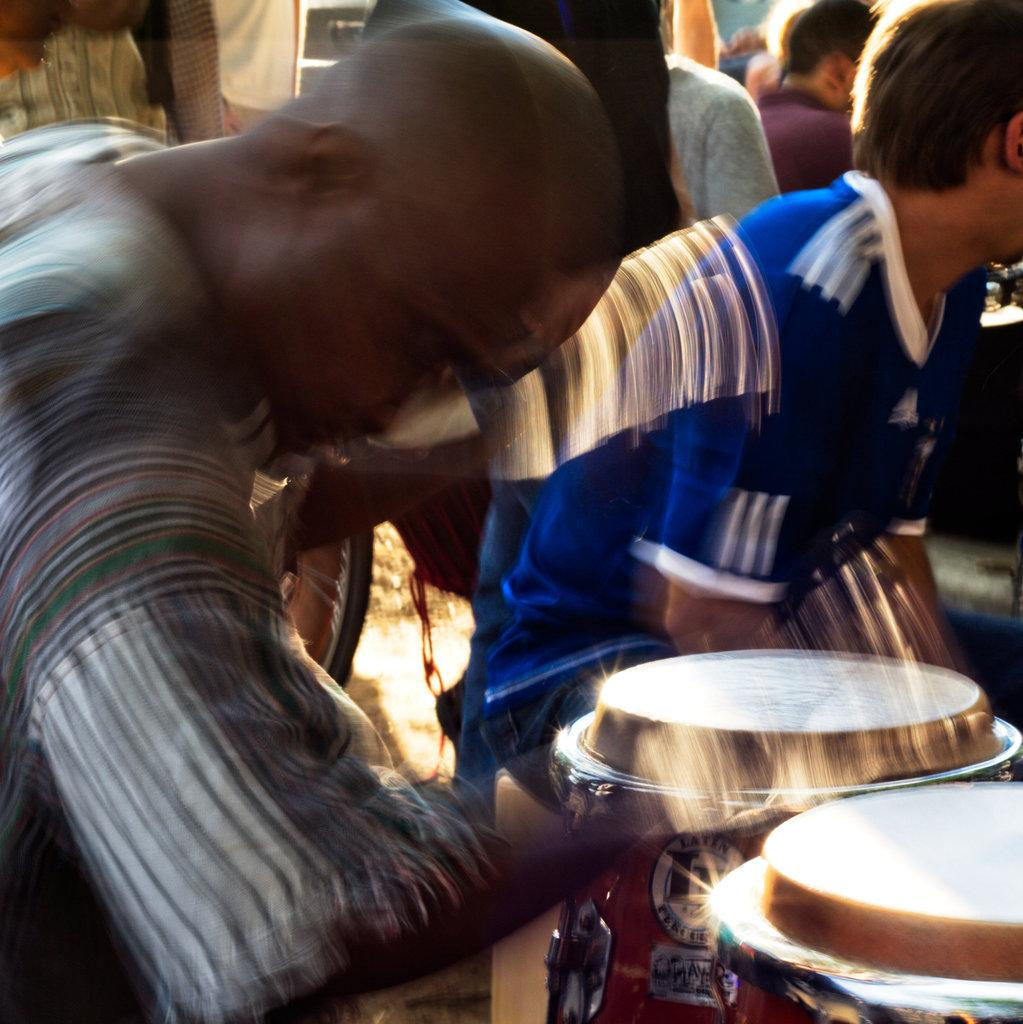What musical instruments are located in the bottom right corner of the image? There are drums in the bottom right corner of the image. Can you describe the people in the background of the image? Unfortunately, the provided facts do not give any information about the people in the background. What type of playground equipment can be seen in the image? There is no playground equipment present in the image. What hope does the image convey? The image does not convey any specific hope, as it only shows drums and people in the background. 